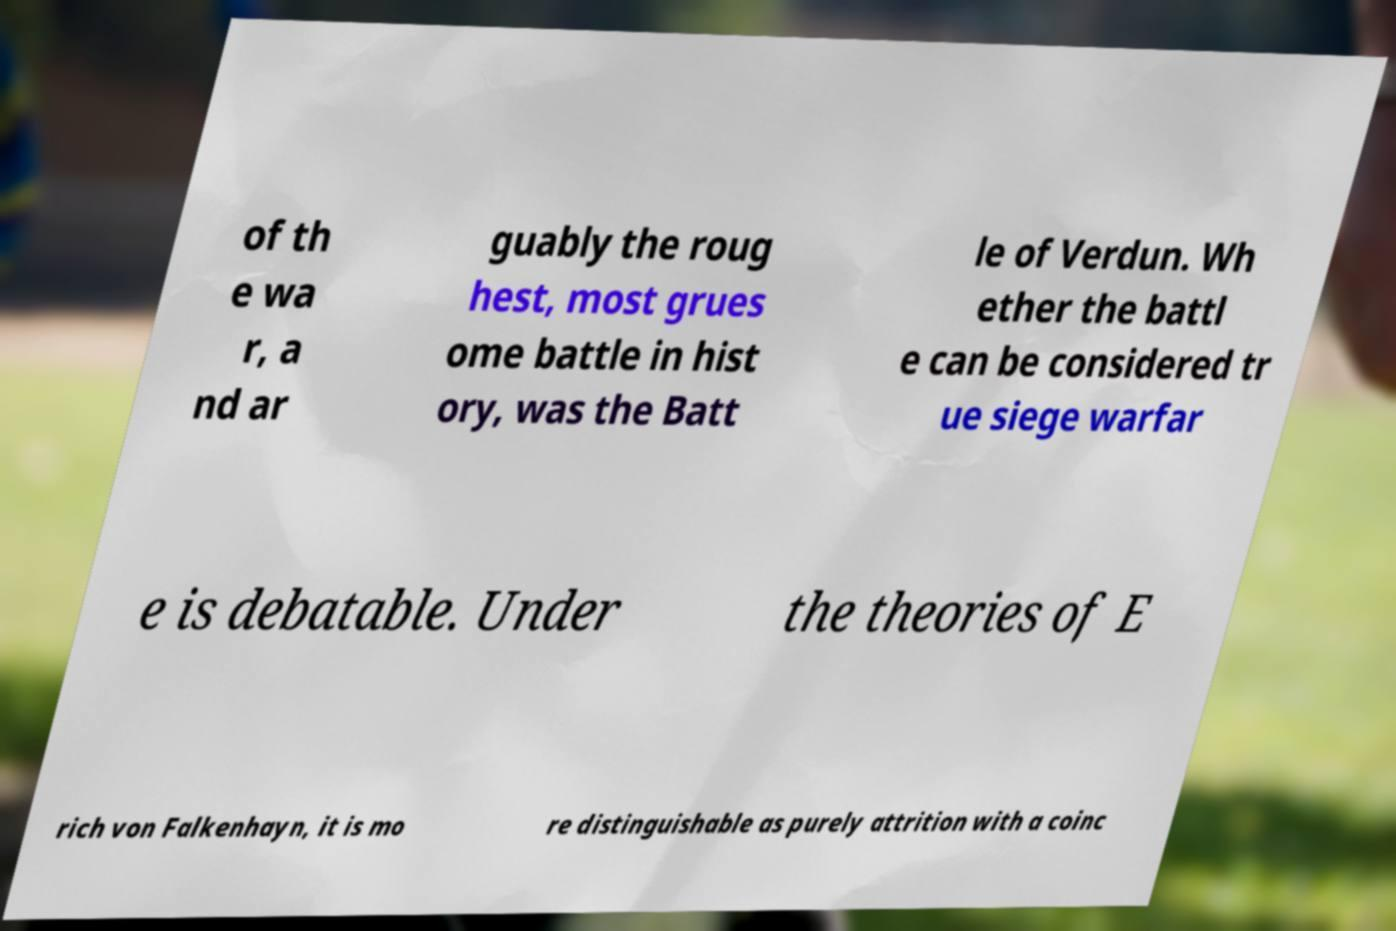Please identify and transcribe the text found in this image. of th e wa r, a nd ar guably the roug hest, most grues ome battle in hist ory, was the Batt le of Verdun. Wh ether the battl e can be considered tr ue siege warfar e is debatable. Under the theories of E rich von Falkenhayn, it is mo re distinguishable as purely attrition with a coinc 